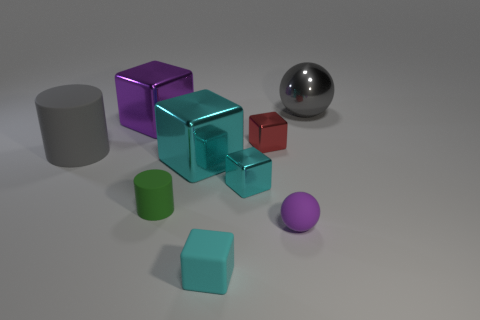What number of red things are metal blocks or shiny cylinders?
Your response must be concise. 1. There is a cyan cube that is in front of the tiny green object that is in front of the gray object that is left of the small red object; what is its size?
Offer a terse response. Small. There is a purple rubber thing that is the same shape as the gray metal thing; what is its size?
Provide a short and direct response. Small. How many tiny things are brown rubber balls or metallic spheres?
Provide a short and direct response. 0. Is the material of the gray object that is right of the rubber cube the same as the purple object behind the purple sphere?
Make the answer very short. Yes. What material is the cylinder to the left of the purple metal cube?
Your response must be concise. Rubber. How many metal objects are either large yellow things or large objects?
Provide a succinct answer. 3. There is a cylinder in front of the large gray object in front of the red metal thing; what is its color?
Your answer should be very brief. Green. Do the purple sphere and the big gray object in front of the red metal object have the same material?
Provide a succinct answer. Yes. There is a small rubber thing that is right of the tiny metal thing behind the cylinder to the left of the green matte cylinder; what color is it?
Offer a very short reply. Purple. 